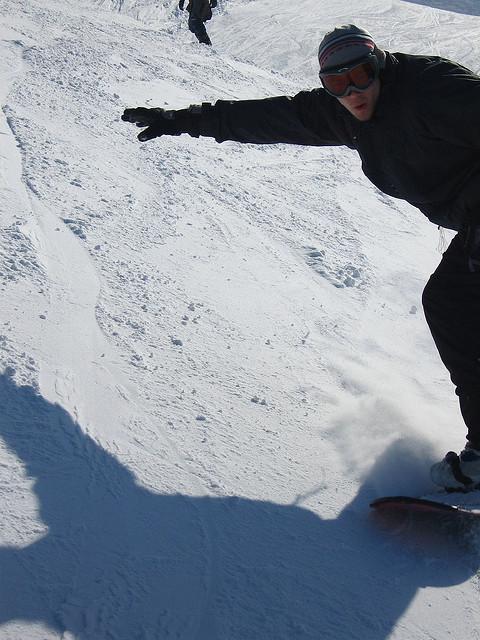Why is he walking up-hill?
Quick response, please. He isn't. What is this person doing?
Short answer required. Snowboarding. Is this person wearing a hat?
Answer briefly. Yes. Do you think that snowboarder is goofy or regular footed?
Answer briefly. Regular. Where is this picture taken?
Write a very short answer. Mountain. What color are his goggles?
Be succinct. Black. What keeps the man's hands warm?
Quick response, please. Gloves. 